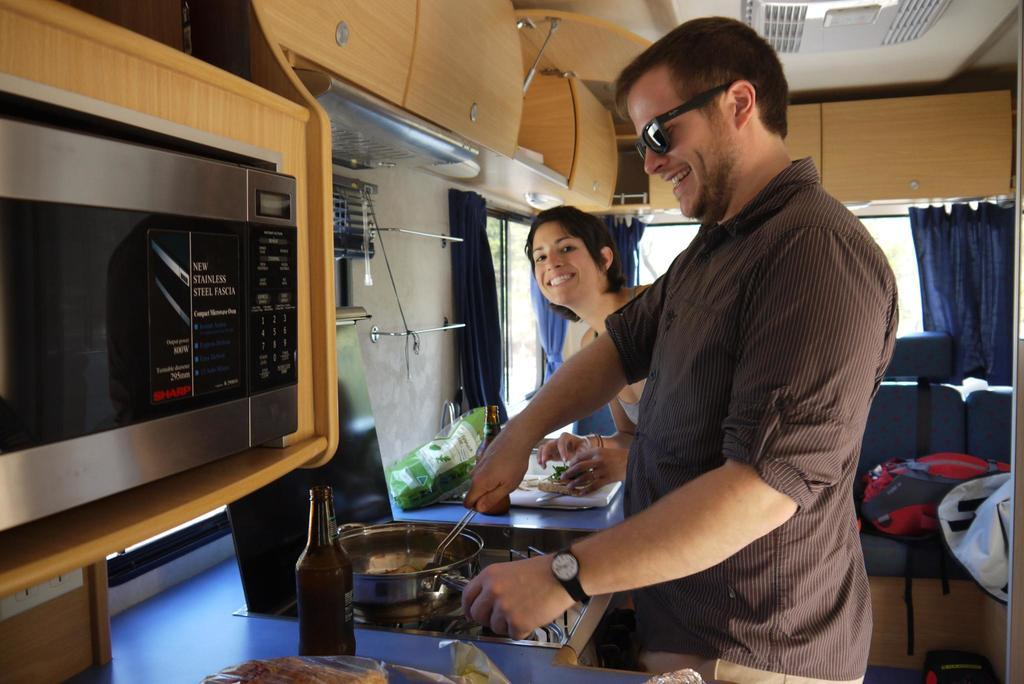<image>
Provide a brief description of the given image. A woman and a man cook by a New Stainless Steel Fascia 